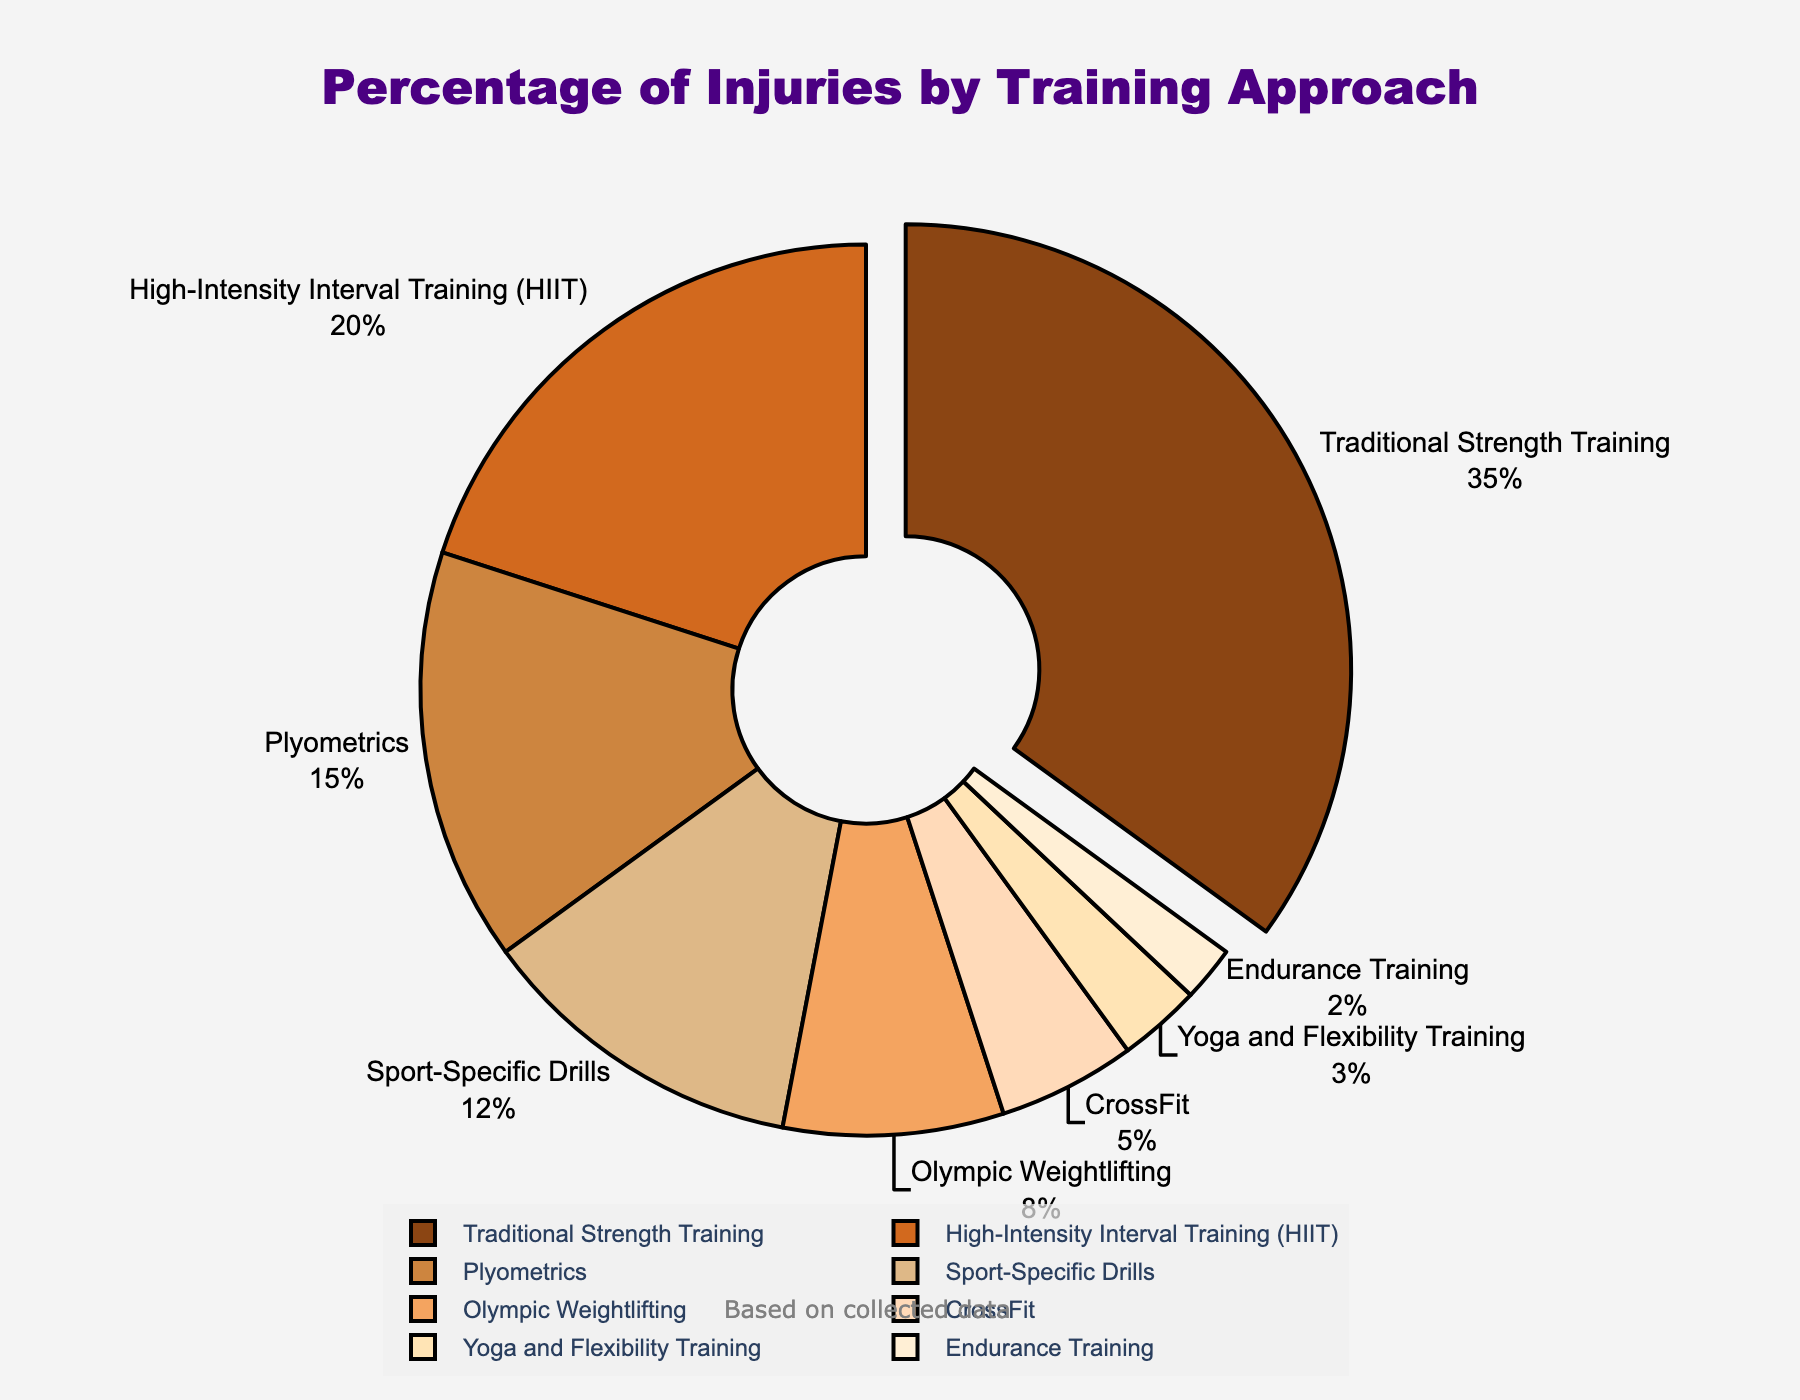Which training approach accounts for the highest percentage of injuries? By looking at the slices of the pie chart, the largest slice represents the training approach with the highest percentage of injuries.
Answer: Traditional Strength Training What is the combined percentage of injuries attributed to High-Intensity Interval Training (HIIT) and Plyometrics? Add the percentages of injuries for High-Intensity Interval Training (20%) and Plyometrics (15%), giving a total of 20% + 15%.
Answer: 35% Which training approach has the smallest percentage of injuries? By identifying the smallest slice in the pie chart, you find the training approach with the smallest percentage of injuries.
Answer: Endurance Training How much more frequent are injuries in Sport-Specific Drills compared to Yoga and Flexibility Training? Subtract the percentage of injuries for Yoga and Flexibility Training (3%) from the percentage for Sport-Specific Drills (12%) to find the difference.
Answer: 9% What is the average percentage of injuries among Olympic Weightlifting, CrossFit, and Yoga and Flexibility Training? Add the percentage of injuries for Olympic Weightlifting (8%), CrossFit (5%), and Yoga and Flexibility Training (3%), then divide by the number of approaches (3). The calculation is (8% + 5% + 3%) / 3.
Answer: 5.33% Is the percentage of injuries in Plyometrics greater than in High-Intensity Interval Training (HIIT)? Compare the percentages of injuries for Plyometrics (15%) and HIIT (20%), where Plyometrics (15%) is less than HIIT (20%).
Answer: No What is the percentage difference between Traditional Strength Training and CrossFit? Subtract the percentage of injuries for CrossFit (5%) from Traditional Strength Training (35%).
Answer: 30% How many training approaches have a percentage of injuries less than 10%? Count the slices that represent training approaches with percentages of injuries less than 10%: Olympic Weightlifting (8%), CrossFit (5%), Yoga and Flexibility Training (3%), Endurance Training (2%).
Answer: 4 What percentage of injuries does Traditional Strength Training contribute relative to the total injuries from Sport-Specific Drills, Olympic Weightlifting, and CrossFit combined? Calculate the combined percentage of injuries for Sport-Specific Drills (12%), Olympic Weightlifting (8%), and CrossFit (5%). Then, divide Traditional Strength Training (35%) by the combined percentage and multiply by 100 to get the relative contribution: 35% / (12% + 8% + 5%) * 100.
Answer: 116.67% Are there more injuries from High-Intensity Interval Training (HIIT) than from the combined percentage of CrossFit and Yoga and Flexibility Training? Calculate the sum of percentage injuries for CrossFit (5%) and Yoga and Flexibility Training (3%), then compare this to the HIIT percentage (20%). Since 5% + 3% is 8%, which is less than 20%, HIIT has more.
Answer: Yes 